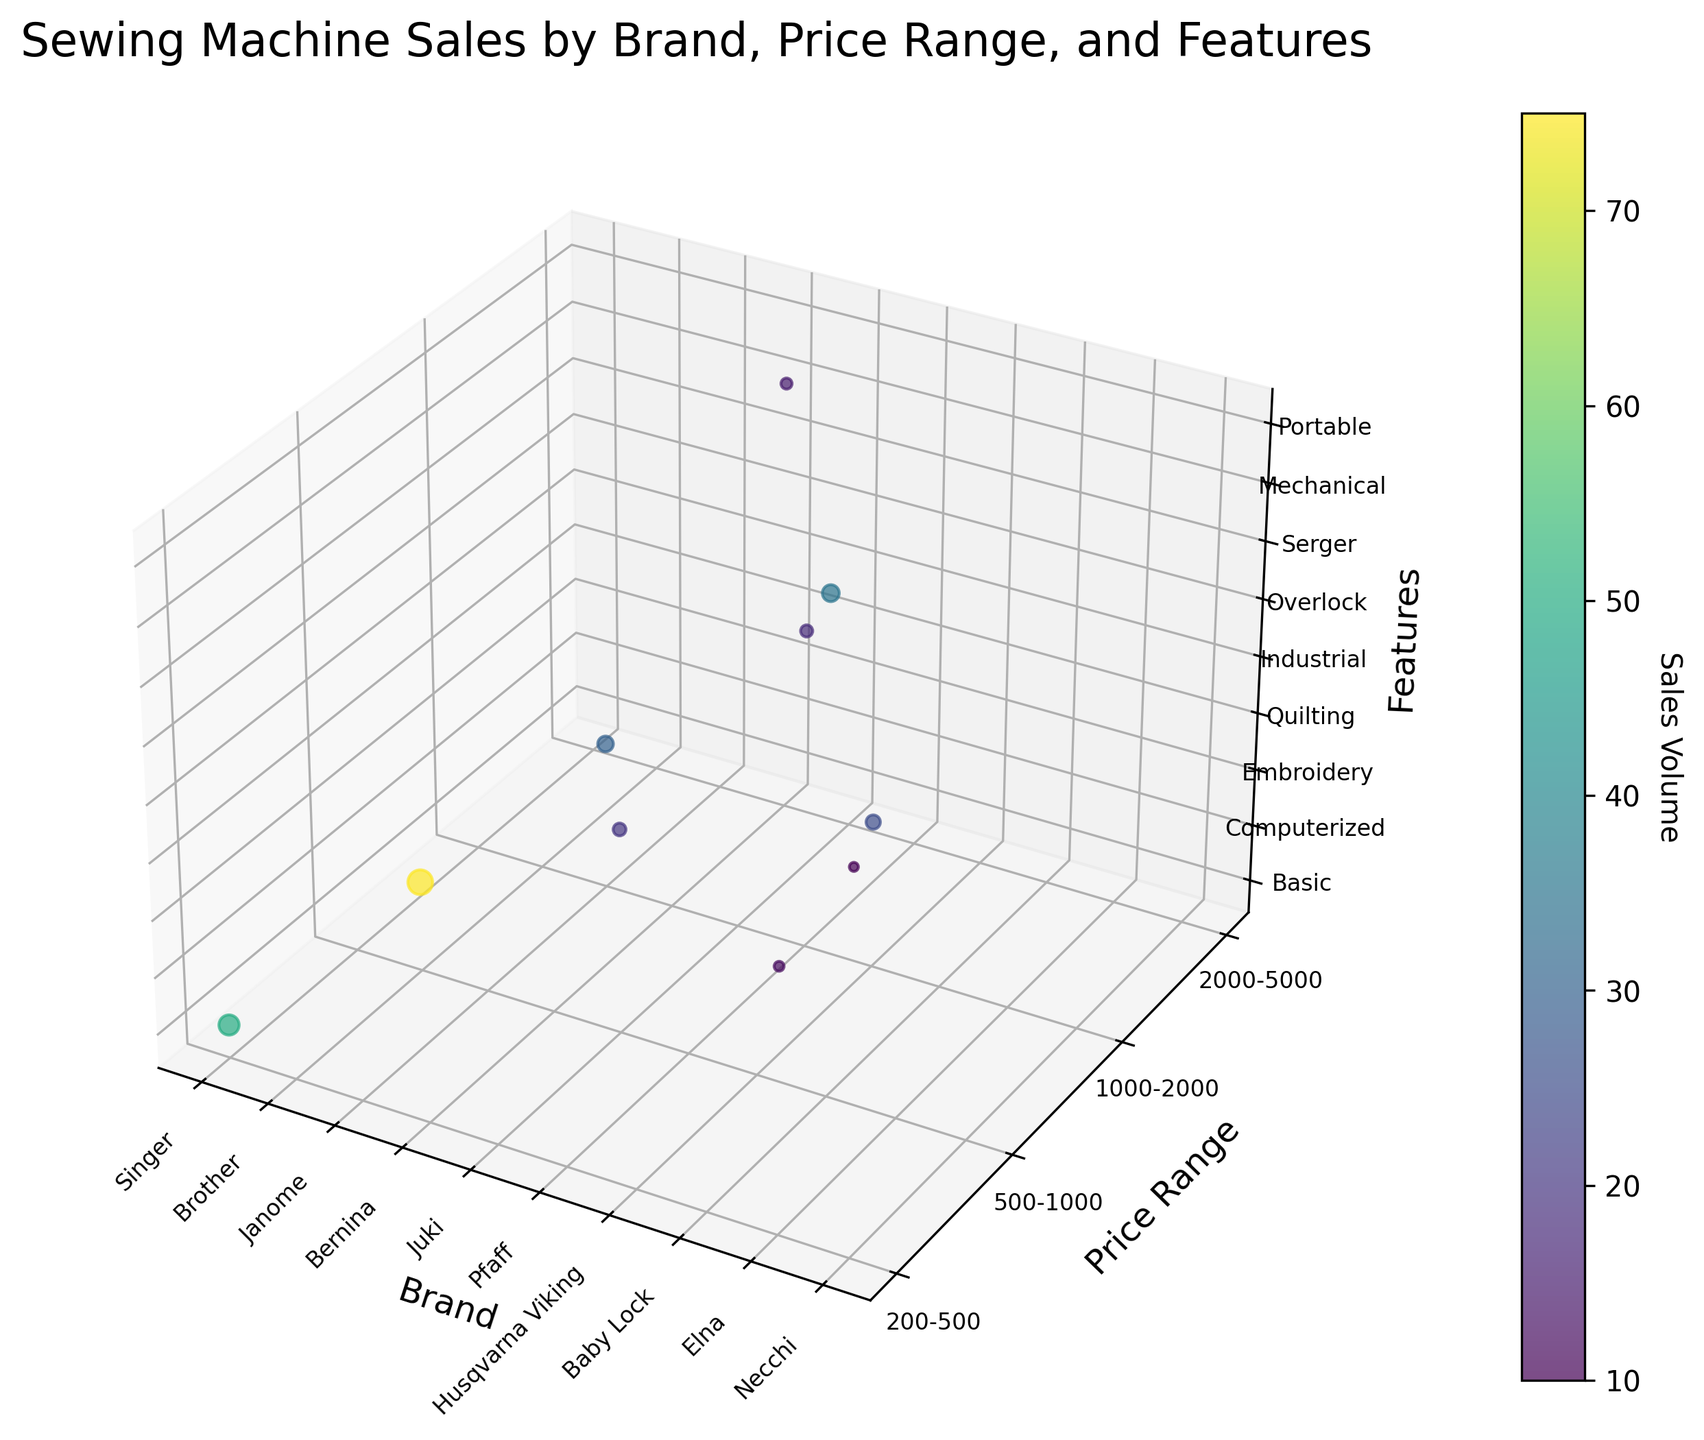What is the title of the chart? The title is usually placed at the top of the chart. In this case, it reads "Sewing Machine Sales by Brand, Price Range, and Features."
Answer: Sewing Machine Sales by Brand, Price Range, and Features How many different brands are represented in the chart? The x-axis represents the various brands and has distinct labels for each. By counting these labels, we identify 10 different brands.
Answer: 10 Which brand has the highest sales volume? The size and color of the bubbles indicate the sales volume. The largest and darkest bubble corresponds to the brand with the highest sales volume, which is Brother.
Answer: Brother What price range does the brand Janome belong to? The y-axis indicates the price range, categorized from 1 to 4. The Janome bubble is aligned with y=3, corresponding to the '1000-2000' price range.
Answer: 1000-2000 Which feature category is associated with the brand Bernina? The z-axis represents features, and each brand's alignment along the z-axis denotes the feature. Bernina is aligned with the 'Quilting' category.
Answer: Quilting Based on the chart, which brand in the '200-500' price range has the lowest sales volume? In the '200-500' price range (y=1), comparing the sizes of the bubbles for the brands Elna and Necchi, Necchi has the smaller bubble, indicating the lowest sales volume.
Answer: Necchi What's the total sales volume for brands in the '500-1000' price range? The bubbles in the '500-1000' range (y=2) correspond to Brother, Juki, and Baby Lock. Adding their sales volumes: 7500 + 2000 + 3500 = 13000.
Answer: 13000 Which feature is most popular in terms of the number of brands offering it? By counting the bubbles aligned with each feature on the z-axis, 'Embroidery' has the most bubbles (2 brands: Janome and Husqvarna Viking).
Answer: Embroidery What price range does the feature 'Overlock' fall into? By examining the bubble for 'Overlock' (Pfaff), it aligns with y=3, corresponding to the '1000-2000' price range.
Answer: 1000-2000 Which brand combines a 'Portable' feature with a price range of '200-500'? The combination is found by locating the bubble in the 'Portable' z-axis category and the '200-500' y-axis range. It aligns with Necchi.
Answer: Necchi 